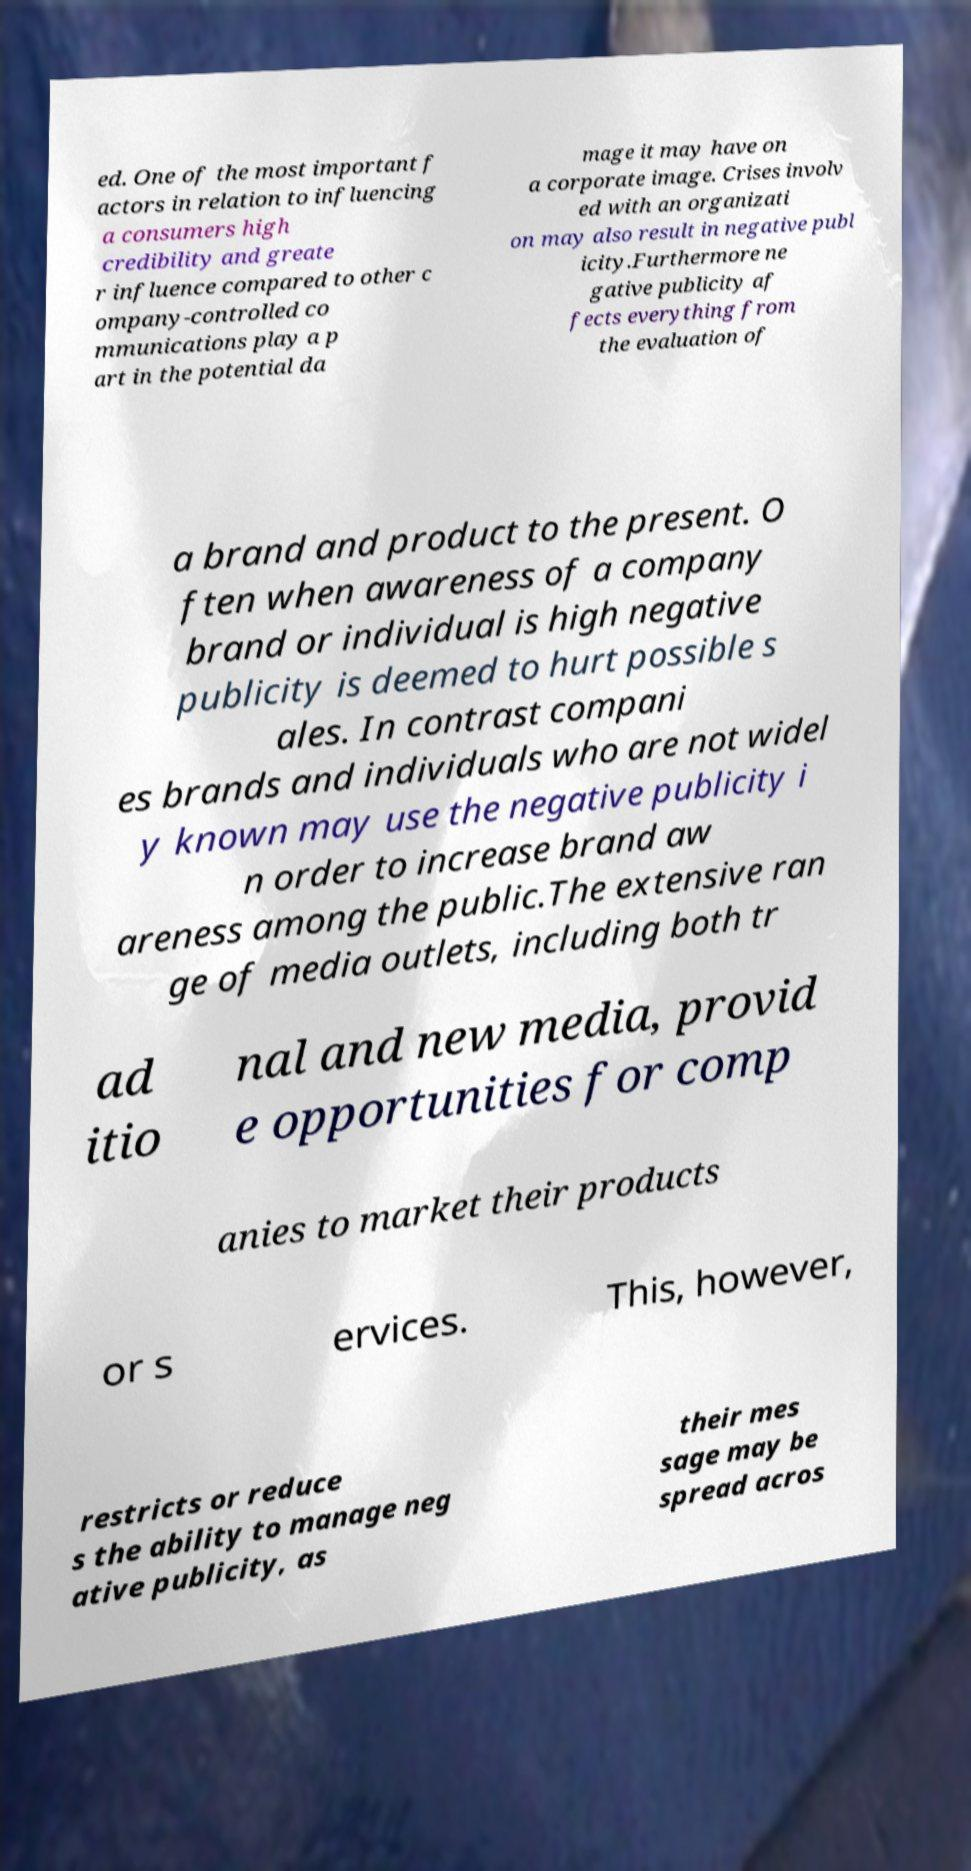Can you accurately transcribe the text from the provided image for me? ed. One of the most important f actors in relation to influencing a consumers high credibility and greate r influence compared to other c ompany-controlled co mmunications play a p art in the potential da mage it may have on a corporate image. Crises involv ed with an organizati on may also result in negative publ icity.Furthermore ne gative publicity af fects everything from the evaluation of a brand and product to the present. O ften when awareness of a company brand or individual is high negative publicity is deemed to hurt possible s ales. In contrast compani es brands and individuals who are not widel y known may use the negative publicity i n order to increase brand aw areness among the public.The extensive ran ge of media outlets, including both tr ad itio nal and new media, provid e opportunities for comp anies to market their products or s ervices. This, however, restricts or reduce s the ability to manage neg ative publicity, as their mes sage may be spread acros 